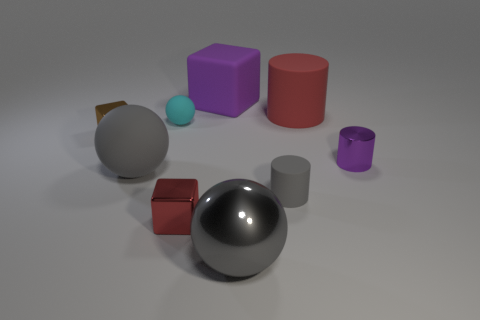What number of other things are there of the same color as the big shiny ball?
Provide a short and direct response. 2. Are the big cylinder and the gray object left of the big block made of the same material?
Your response must be concise. Yes. There is a red thing that is in front of the purple cylinder; what material is it?
Your answer should be compact. Metal. How big is the gray metallic thing?
Make the answer very short. Large. There is a purple thing that is on the left side of the big red rubber cylinder; is it the same size as the shiny object that is to the left of the red block?
Offer a very short reply. No. What size is the other matte thing that is the same shape as the tiny brown thing?
Give a very brief answer. Large. Is the size of the gray rubber cylinder the same as the rubber sphere in front of the small cyan sphere?
Ensure brevity in your answer.  No. Is there a matte object on the left side of the large ball on the right side of the purple matte block?
Your response must be concise. Yes. What shape is the gray object that is to the right of the gray metal thing?
Offer a very short reply. Cylinder. There is a tiny object that is the same color as the large block; what material is it?
Keep it short and to the point. Metal. 